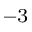<formula> <loc_0><loc_0><loc_500><loc_500>^ { - 3 }</formula> 